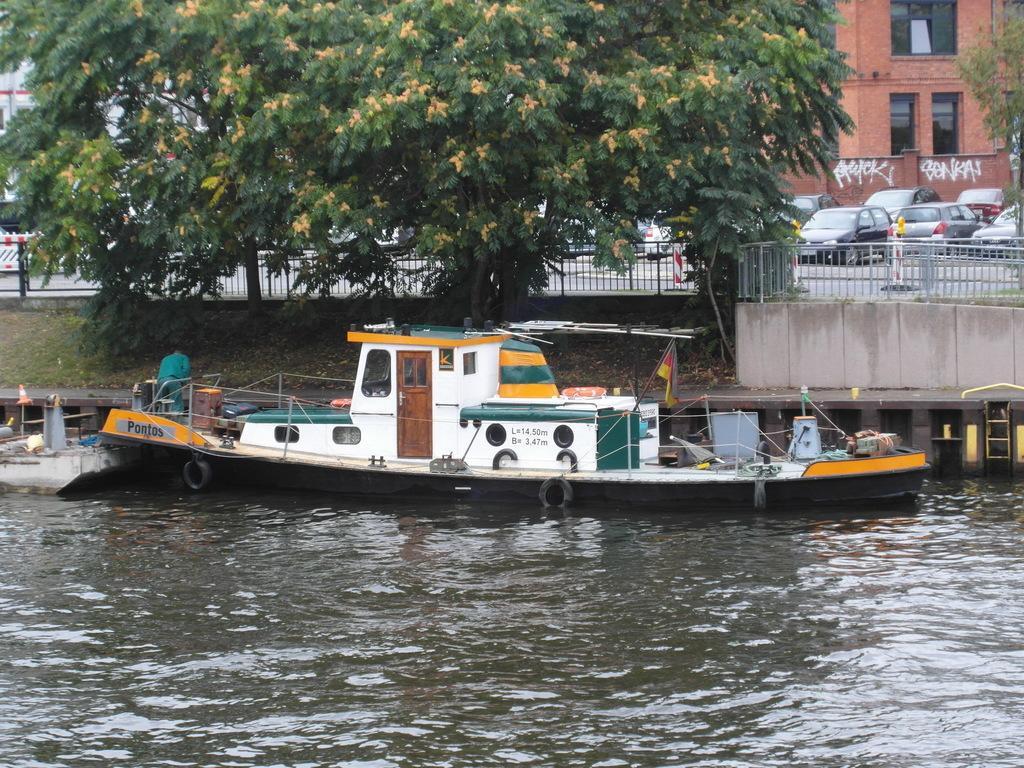Can you describe this image briefly? This is an outdoor picture. This is a freshwater river. The boat is floating on a river. The door is in brown color. This is a tree, which is in green and yellow color. The fence is in black color. Far there is a building in red color with a window. Vehicles on a road. 